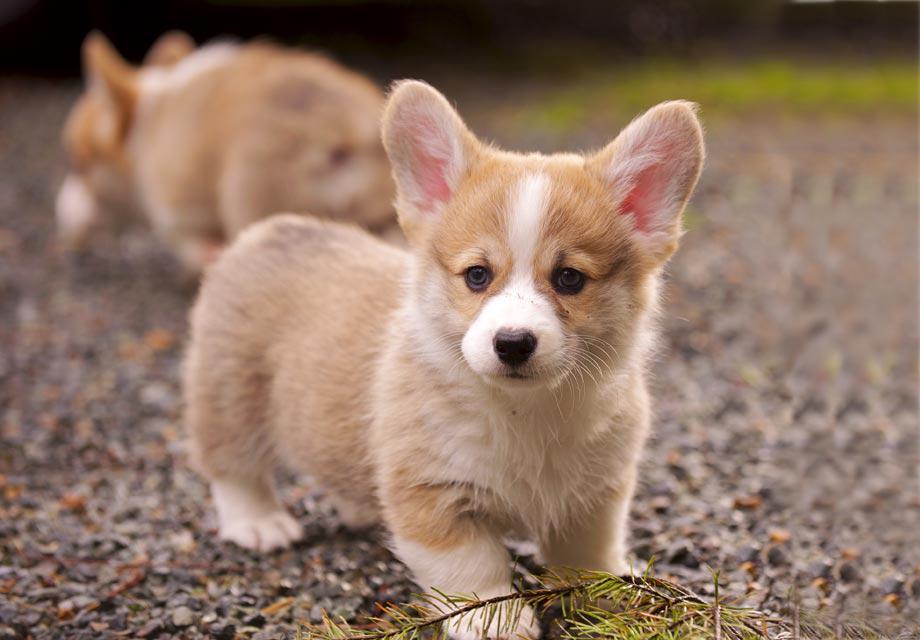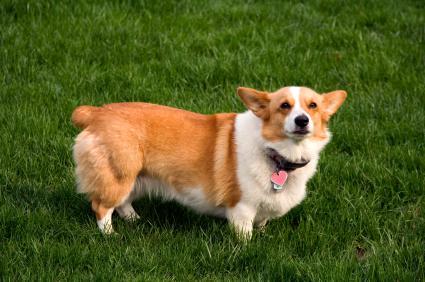The first image is the image on the left, the second image is the image on the right. Assess this claim about the two images: "One image contains twice as many dogs as the other image.". Correct or not? Answer yes or no. Yes. The first image is the image on the left, the second image is the image on the right. Evaluate the accuracy of this statement regarding the images: "Two corgies sit side by side in one image, while another corgi with its mouth open and tongue showing is alone in the other image.". Is it true? Answer yes or no. No. The first image is the image on the left, the second image is the image on the right. Analyze the images presented: Is the assertion "At least one dog is sitting in the grass." valid? Answer yes or no. No. The first image is the image on the left, the second image is the image on the right. For the images shown, is this caption "The right image includes twice the number of dogs as the left image." true? Answer yes or no. No. 